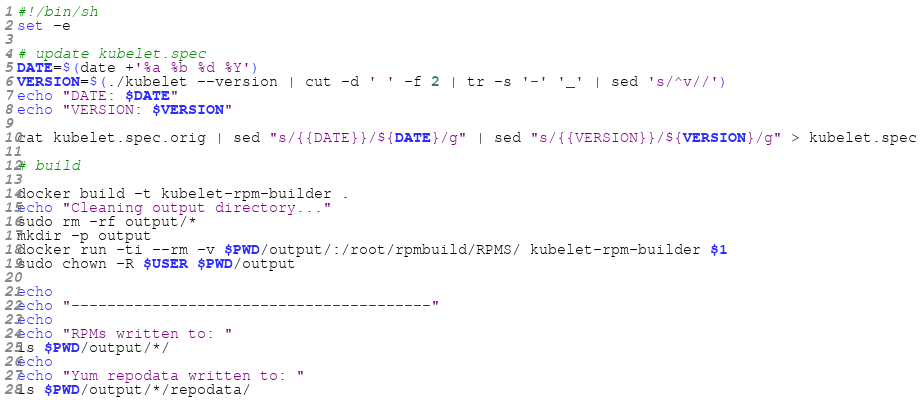<code> <loc_0><loc_0><loc_500><loc_500><_Bash_>#!/bin/sh
set -e

# update kubelet.spec
DATE=$(date +'%a %b %d %Y')
VERSION=$(./kubelet --version | cut -d ' ' -f 2 | tr -s '-' '_' | sed 's/^v//')
echo "DATE: $DATE"
echo "VERSION: $VERSION"

cat kubelet.spec.orig | sed "s/{{DATE}}/${DATE}/g" | sed "s/{{VERSION}}/${VERSION}/g" > kubelet.spec

# build

docker build -t kubelet-rpm-builder .
echo "Cleaning output directory..."
sudo rm -rf output/*
mkdir -p output
docker run -ti --rm -v $PWD/output/:/root/rpmbuild/RPMS/ kubelet-rpm-builder $1
sudo chown -R $USER $PWD/output

echo
echo "----------------------------------------"
echo
echo "RPMs written to: "
ls $PWD/output/*/
echo
echo "Yum repodata written to: "
ls $PWD/output/*/repodata/
</code> 